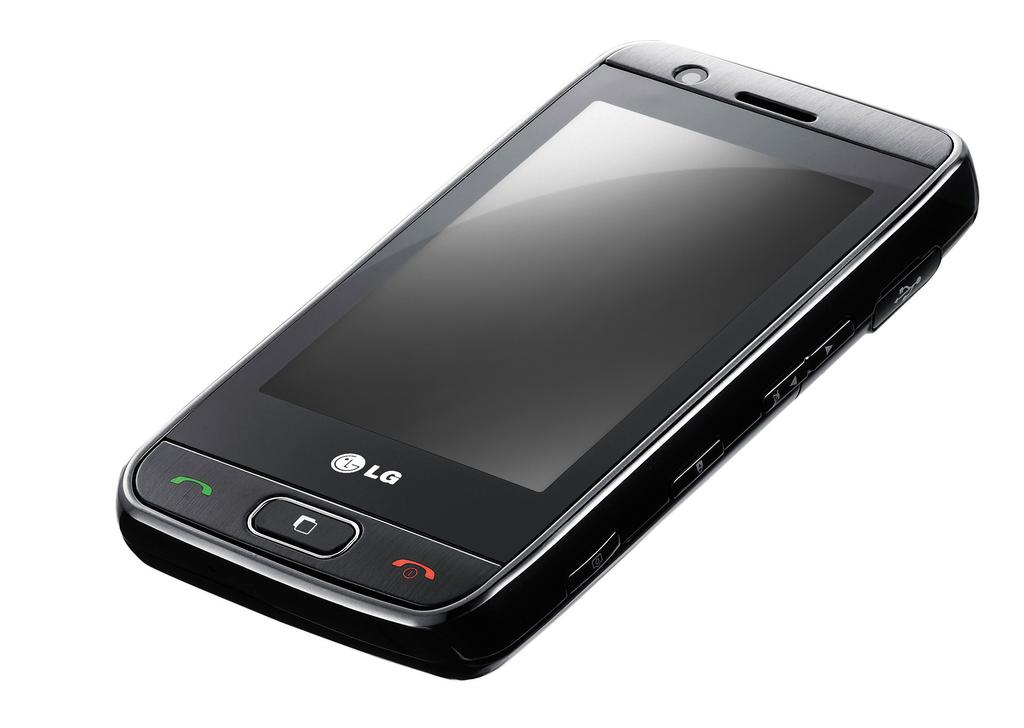<image>
Share a concise interpretation of the image provided. A black LG brand cell phone with a red and green phone display buttons 